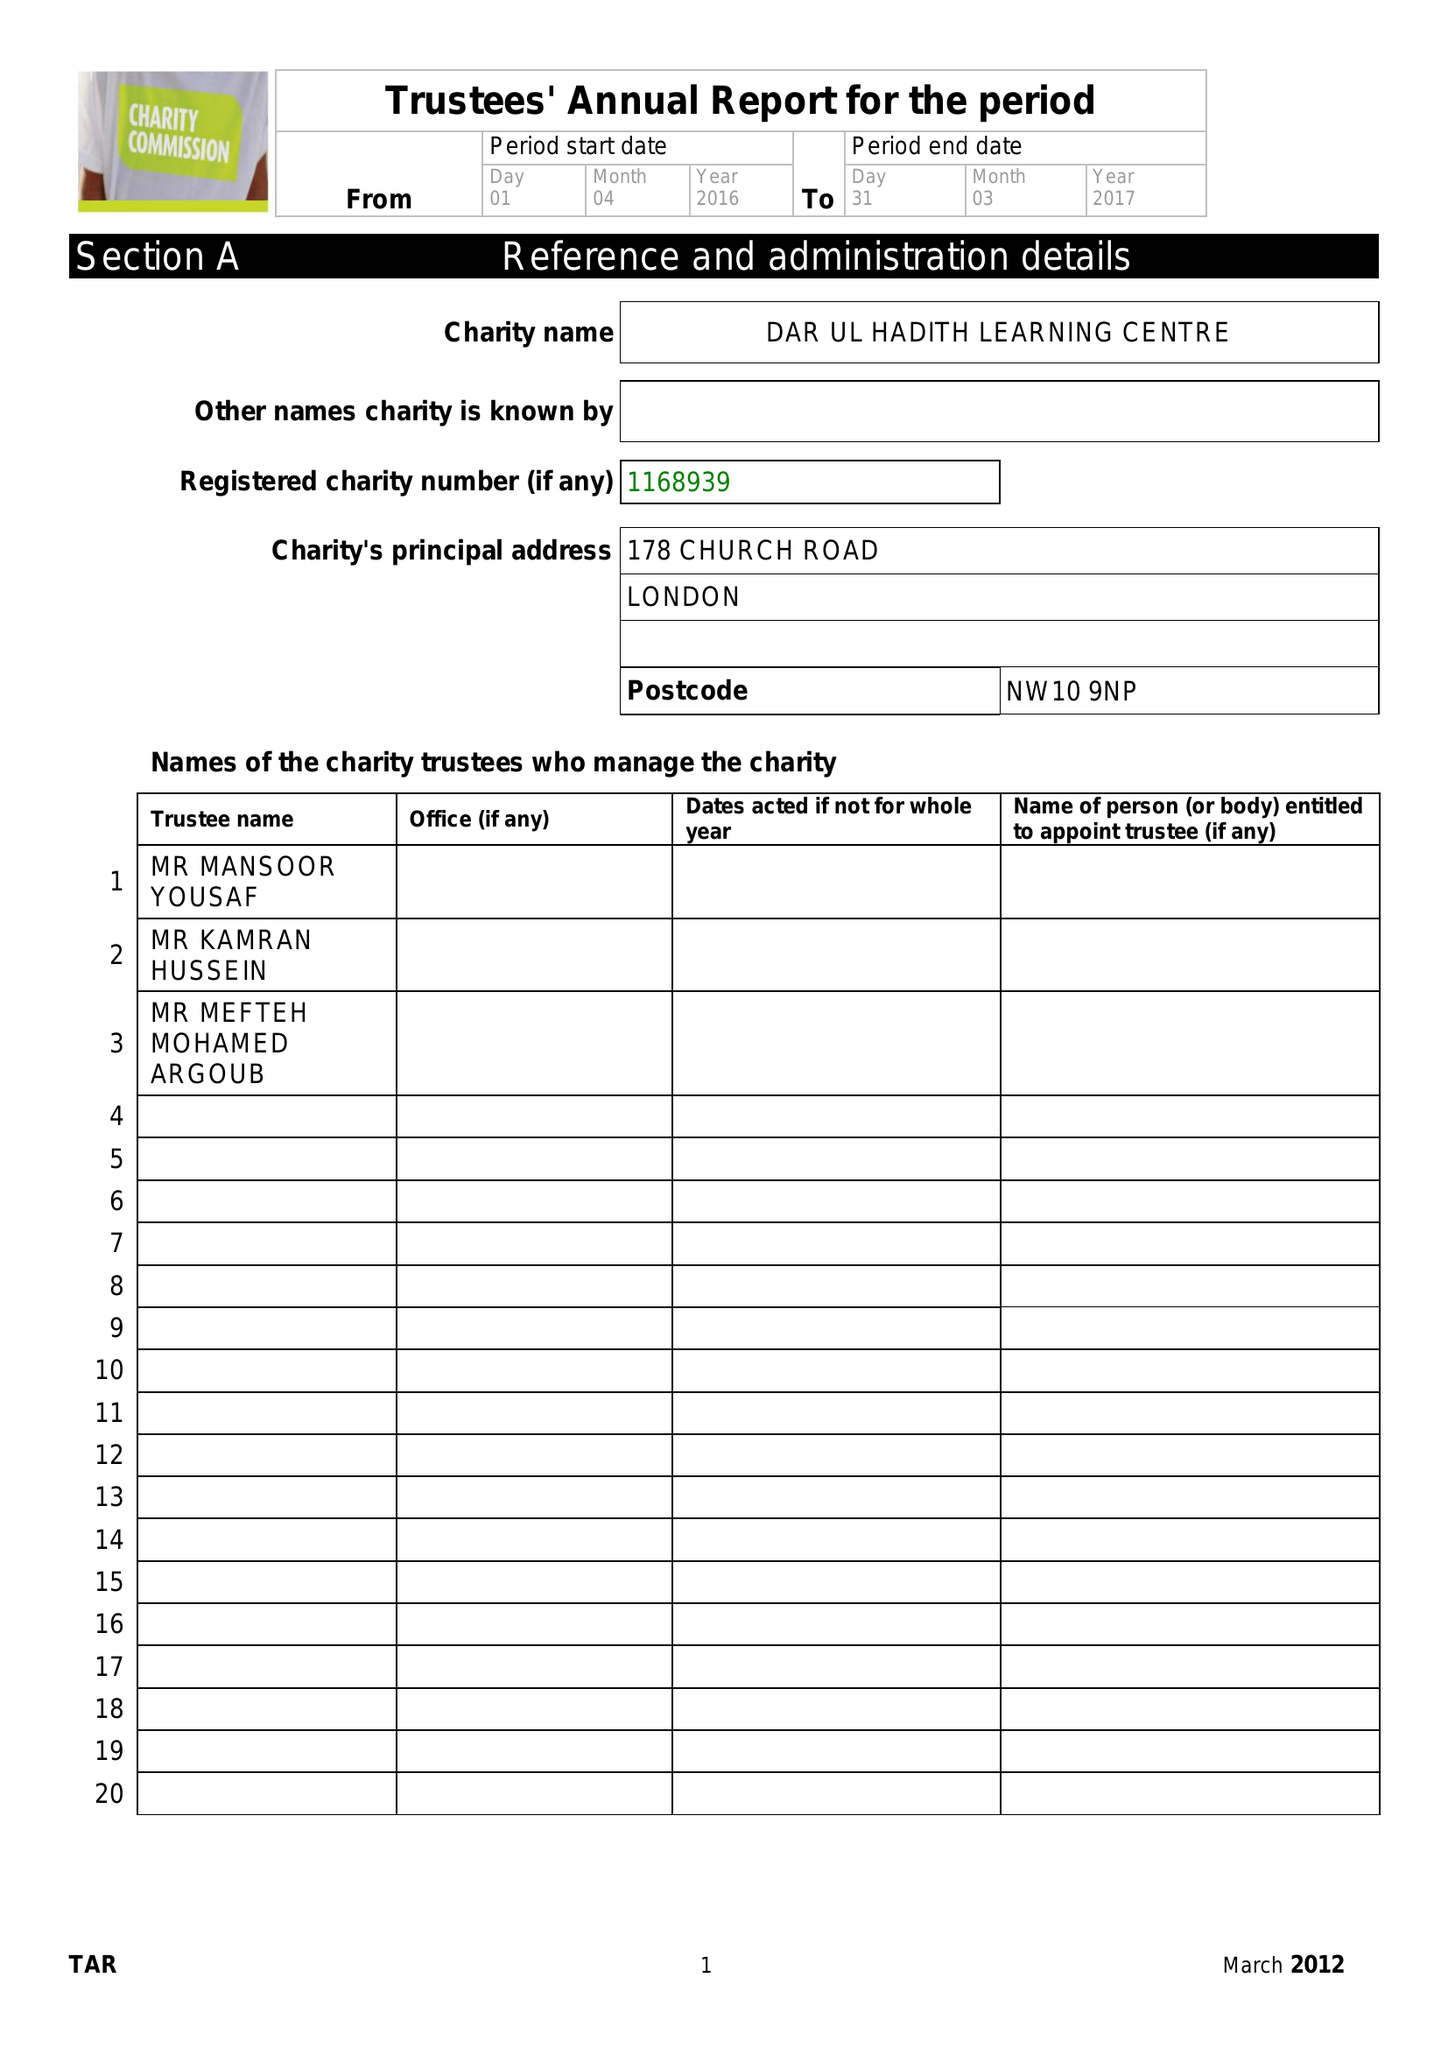What is the value for the address__postcode?
Answer the question using a single word or phrase. NW10 9NP 